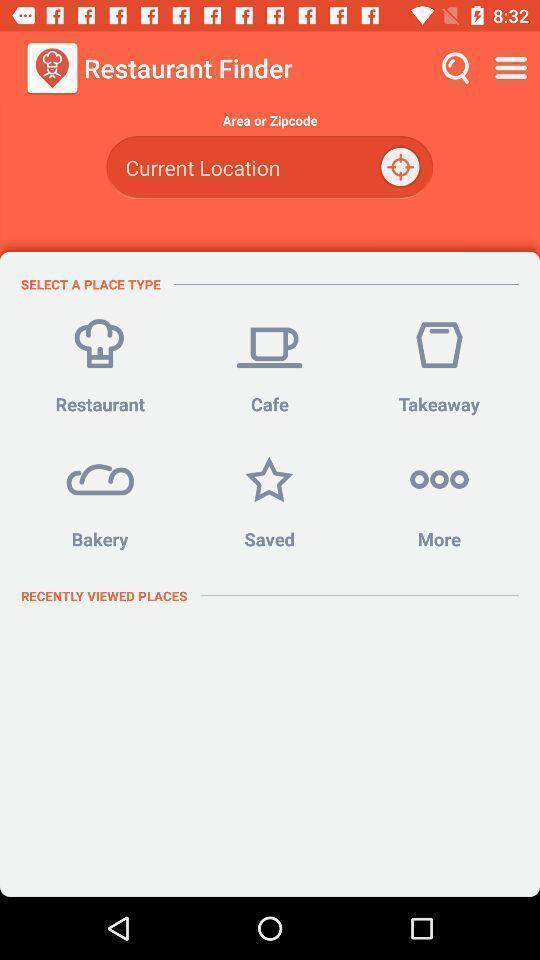Describe the key features of this screenshot. Page showing select a place type. 